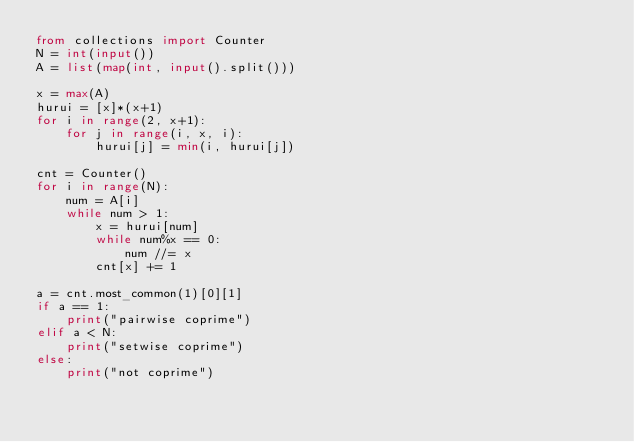<code> <loc_0><loc_0><loc_500><loc_500><_Python_>from collections import Counter
N = int(input())
A = list(map(int, input().split()))

x = max(A)
hurui = [x]*(x+1)
for i in range(2, x+1):
    for j in range(i, x, i):
        hurui[j] = min(i, hurui[j])

cnt = Counter()
for i in range(N):
    num = A[i]
    while num > 1:
        x = hurui[num]
        while num%x == 0:
            num //= x
        cnt[x] += 1

a = cnt.most_common(1)[0][1]
if a == 1:
    print("pairwise coprime")
elif a < N:
    print("setwise coprime")
else:
    print("not coprime")
</code> 